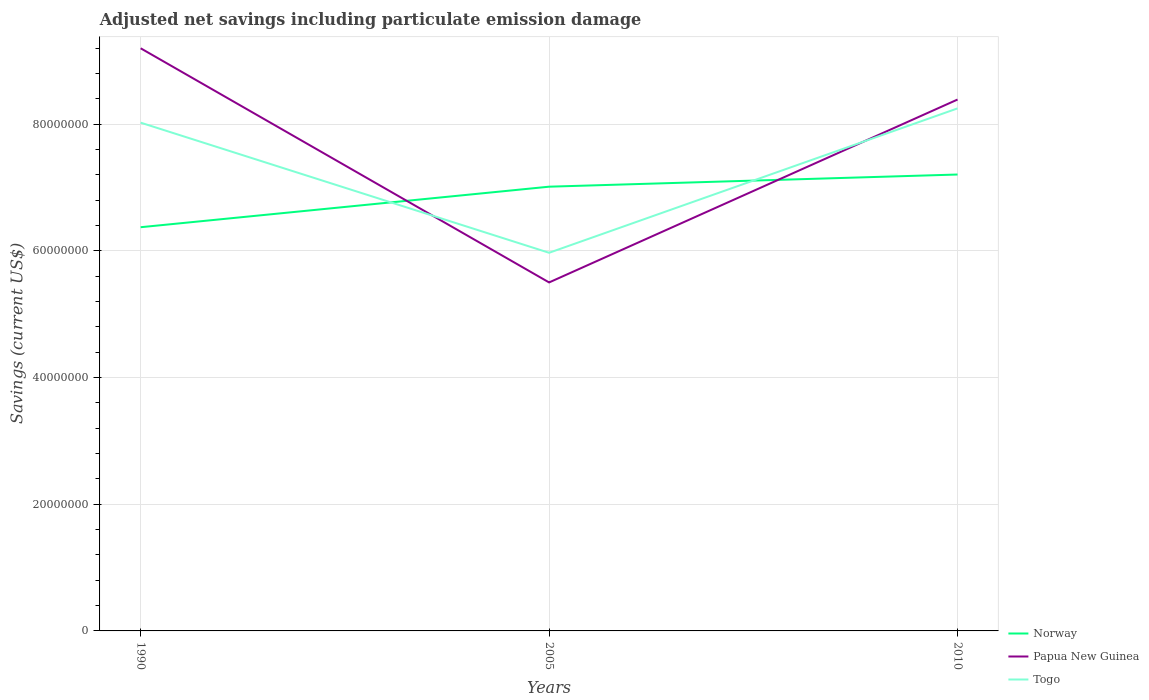How many different coloured lines are there?
Give a very brief answer. 3. Across all years, what is the maximum net savings in Togo?
Ensure brevity in your answer.  5.97e+07. In which year was the net savings in Togo maximum?
Ensure brevity in your answer.  2005. What is the total net savings in Norway in the graph?
Keep it short and to the point. -1.92e+06. What is the difference between the highest and the second highest net savings in Togo?
Offer a very short reply. 2.28e+07. Are the values on the major ticks of Y-axis written in scientific E-notation?
Provide a succinct answer. No. Does the graph contain any zero values?
Make the answer very short. No. Where does the legend appear in the graph?
Your answer should be very brief. Bottom right. How many legend labels are there?
Your response must be concise. 3. How are the legend labels stacked?
Keep it short and to the point. Vertical. What is the title of the graph?
Offer a terse response. Adjusted net savings including particulate emission damage. Does "Bermuda" appear as one of the legend labels in the graph?
Ensure brevity in your answer.  No. What is the label or title of the Y-axis?
Give a very brief answer. Savings (current US$). What is the Savings (current US$) in Norway in 1990?
Give a very brief answer. 6.37e+07. What is the Savings (current US$) in Papua New Guinea in 1990?
Your answer should be compact. 9.20e+07. What is the Savings (current US$) in Togo in 1990?
Your answer should be compact. 8.02e+07. What is the Savings (current US$) of Norway in 2005?
Offer a very short reply. 7.01e+07. What is the Savings (current US$) of Papua New Guinea in 2005?
Ensure brevity in your answer.  5.50e+07. What is the Savings (current US$) of Togo in 2005?
Your response must be concise. 5.97e+07. What is the Savings (current US$) in Norway in 2010?
Your answer should be very brief. 7.21e+07. What is the Savings (current US$) of Papua New Guinea in 2010?
Offer a terse response. 8.39e+07. What is the Savings (current US$) in Togo in 2010?
Your response must be concise. 8.25e+07. Across all years, what is the maximum Savings (current US$) of Norway?
Your response must be concise. 7.21e+07. Across all years, what is the maximum Savings (current US$) of Papua New Guinea?
Make the answer very short. 9.20e+07. Across all years, what is the maximum Savings (current US$) of Togo?
Your answer should be very brief. 8.25e+07. Across all years, what is the minimum Savings (current US$) in Norway?
Make the answer very short. 6.37e+07. Across all years, what is the minimum Savings (current US$) in Papua New Guinea?
Your answer should be very brief. 5.50e+07. Across all years, what is the minimum Savings (current US$) of Togo?
Keep it short and to the point. 5.97e+07. What is the total Savings (current US$) in Norway in the graph?
Make the answer very short. 2.06e+08. What is the total Savings (current US$) in Papua New Guinea in the graph?
Make the answer very short. 2.31e+08. What is the total Savings (current US$) in Togo in the graph?
Offer a terse response. 2.22e+08. What is the difference between the Savings (current US$) of Norway in 1990 and that in 2005?
Provide a short and direct response. -6.40e+06. What is the difference between the Savings (current US$) in Papua New Guinea in 1990 and that in 2005?
Provide a succinct answer. 3.70e+07. What is the difference between the Savings (current US$) in Togo in 1990 and that in 2005?
Your answer should be very brief. 2.05e+07. What is the difference between the Savings (current US$) in Norway in 1990 and that in 2010?
Your response must be concise. -8.32e+06. What is the difference between the Savings (current US$) in Papua New Guinea in 1990 and that in 2010?
Your answer should be very brief. 8.09e+06. What is the difference between the Savings (current US$) in Togo in 1990 and that in 2010?
Your answer should be very brief. -2.25e+06. What is the difference between the Savings (current US$) of Norway in 2005 and that in 2010?
Your answer should be compact. -1.92e+06. What is the difference between the Savings (current US$) in Papua New Guinea in 2005 and that in 2010?
Your response must be concise. -2.89e+07. What is the difference between the Savings (current US$) of Togo in 2005 and that in 2010?
Your response must be concise. -2.28e+07. What is the difference between the Savings (current US$) of Norway in 1990 and the Savings (current US$) of Papua New Guinea in 2005?
Keep it short and to the point. 8.72e+06. What is the difference between the Savings (current US$) of Norway in 1990 and the Savings (current US$) of Togo in 2005?
Your answer should be very brief. 4.04e+06. What is the difference between the Savings (current US$) of Papua New Guinea in 1990 and the Savings (current US$) of Togo in 2005?
Give a very brief answer. 3.23e+07. What is the difference between the Savings (current US$) in Norway in 1990 and the Savings (current US$) in Papua New Guinea in 2010?
Make the answer very short. -2.02e+07. What is the difference between the Savings (current US$) of Norway in 1990 and the Savings (current US$) of Togo in 2010?
Your answer should be very brief. -1.88e+07. What is the difference between the Savings (current US$) of Papua New Guinea in 1990 and the Savings (current US$) of Togo in 2010?
Make the answer very short. 9.49e+06. What is the difference between the Savings (current US$) of Norway in 2005 and the Savings (current US$) of Papua New Guinea in 2010?
Your answer should be compact. -1.38e+07. What is the difference between the Savings (current US$) in Norway in 2005 and the Savings (current US$) in Togo in 2010?
Ensure brevity in your answer.  -1.24e+07. What is the difference between the Savings (current US$) of Papua New Guinea in 2005 and the Savings (current US$) of Togo in 2010?
Provide a succinct answer. -2.75e+07. What is the average Savings (current US$) in Norway per year?
Provide a short and direct response. 6.86e+07. What is the average Savings (current US$) in Papua New Guinea per year?
Your answer should be compact. 7.70e+07. What is the average Savings (current US$) of Togo per year?
Your answer should be very brief. 7.41e+07. In the year 1990, what is the difference between the Savings (current US$) of Norway and Savings (current US$) of Papua New Guinea?
Provide a short and direct response. -2.82e+07. In the year 1990, what is the difference between the Savings (current US$) of Norway and Savings (current US$) of Togo?
Keep it short and to the point. -1.65e+07. In the year 1990, what is the difference between the Savings (current US$) in Papua New Guinea and Savings (current US$) in Togo?
Ensure brevity in your answer.  1.17e+07. In the year 2005, what is the difference between the Savings (current US$) in Norway and Savings (current US$) in Papua New Guinea?
Your answer should be very brief. 1.51e+07. In the year 2005, what is the difference between the Savings (current US$) in Norway and Savings (current US$) in Togo?
Give a very brief answer. 1.04e+07. In the year 2005, what is the difference between the Savings (current US$) of Papua New Guinea and Savings (current US$) of Togo?
Your answer should be very brief. -4.68e+06. In the year 2010, what is the difference between the Savings (current US$) of Norway and Savings (current US$) of Papua New Guinea?
Provide a succinct answer. -1.18e+07. In the year 2010, what is the difference between the Savings (current US$) of Norway and Savings (current US$) of Togo?
Ensure brevity in your answer.  -1.04e+07. In the year 2010, what is the difference between the Savings (current US$) in Papua New Guinea and Savings (current US$) in Togo?
Your response must be concise. 1.40e+06. What is the ratio of the Savings (current US$) of Norway in 1990 to that in 2005?
Keep it short and to the point. 0.91. What is the ratio of the Savings (current US$) in Papua New Guinea in 1990 to that in 2005?
Give a very brief answer. 1.67. What is the ratio of the Savings (current US$) of Togo in 1990 to that in 2005?
Keep it short and to the point. 1.34. What is the ratio of the Savings (current US$) of Norway in 1990 to that in 2010?
Provide a short and direct response. 0.88. What is the ratio of the Savings (current US$) of Papua New Guinea in 1990 to that in 2010?
Your answer should be compact. 1.1. What is the ratio of the Savings (current US$) of Togo in 1990 to that in 2010?
Provide a succinct answer. 0.97. What is the ratio of the Savings (current US$) of Norway in 2005 to that in 2010?
Your response must be concise. 0.97. What is the ratio of the Savings (current US$) of Papua New Guinea in 2005 to that in 2010?
Your answer should be compact. 0.66. What is the ratio of the Savings (current US$) in Togo in 2005 to that in 2010?
Provide a succinct answer. 0.72. What is the difference between the highest and the second highest Savings (current US$) of Norway?
Keep it short and to the point. 1.92e+06. What is the difference between the highest and the second highest Savings (current US$) of Papua New Guinea?
Provide a short and direct response. 8.09e+06. What is the difference between the highest and the second highest Savings (current US$) of Togo?
Your answer should be compact. 2.25e+06. What is the difference between the highest and the lowest Savings (current US$) of Norway?
Give a very brief answer. 8.32e+06. What is the difference between the highest and the lowest Savings (current US$) in Papua New Guinea?
Make the answer very short. 3.70e+07. What is the difference between the highest and the lowest Savings (current US$) of Togo?
Make the answer very short. 2.28e+07. 